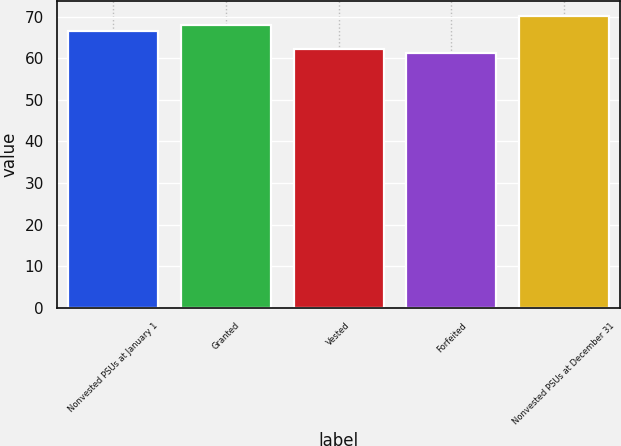Convert chart. <chart><loc_0><loc_0><loc_500><loc_500><bar_chart><fcel>Nonvested PSUs at January 1<fcel>Granted<fcel>Vested<fcel>Forfeited<fcel>Nonvested PSUs at December 31<nl><fcel>66.63<fcel>68.04<fcel>62.1<fcel>61.2<fcel>70.18<nl></chart> 